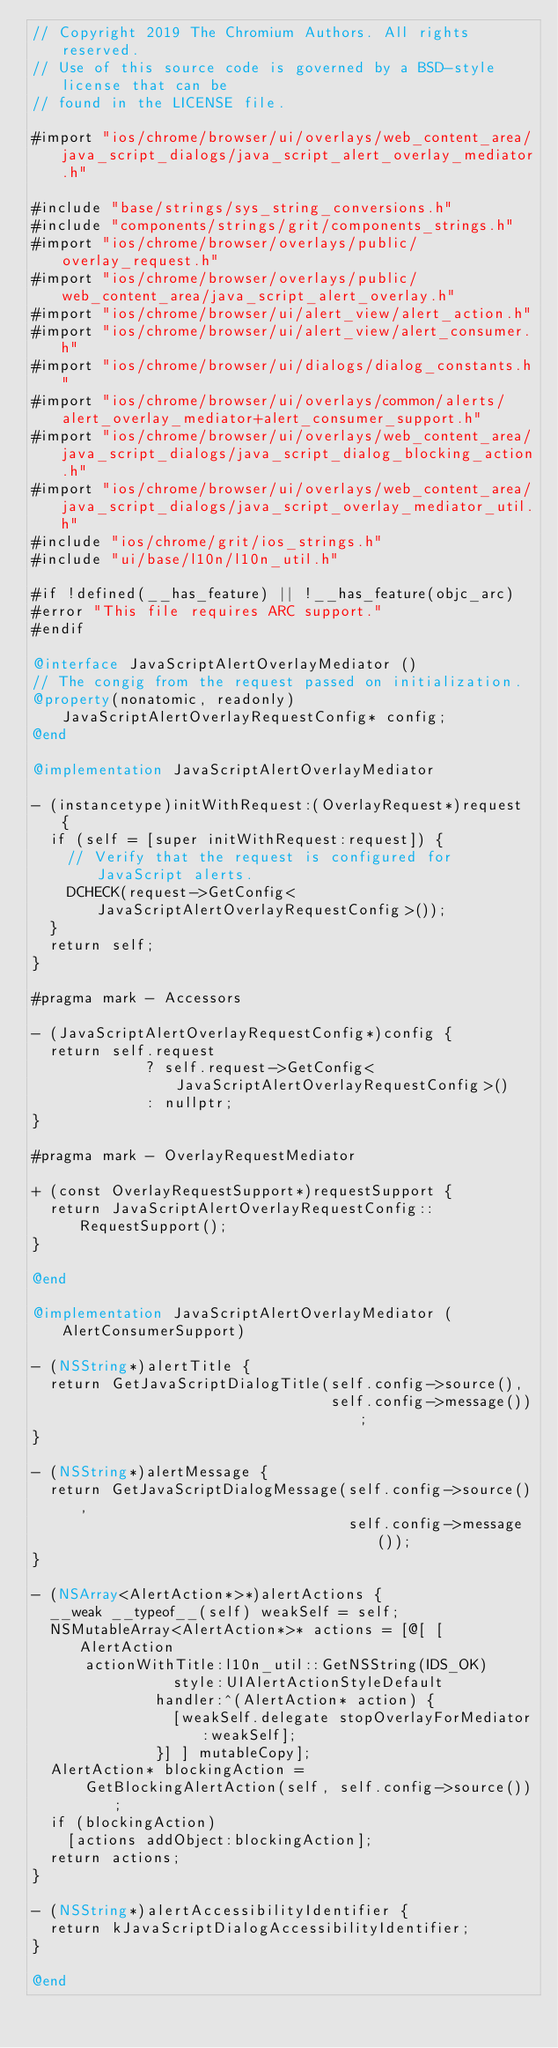<code> <loc_0><loc_0><loc_500><loc_500><_ObjectiveC_>// Copyright 2019 The Chromium Authors. All rights reserved.
// Use of this source code is governed by a BSD-style license that can be
// found in the LICENSE file.

#import "ios/chrome/browser/ui/overlays/web_content_area/java_script_dialogs/java_script_alert_overlay_mediator.h"

#include "base/strings/sys_string_conversions.h"
#include "components/strings/grit/components_strings.h"
#import "ios/chrome/browser/overlays/public/overlay_request.h"
#import "ios/chrome/browser/overlays/public/web_content_area/java_script_alert_overlay.h"
#import "ios/chrome/browser/ui/alert_view/alert_action.h"
#import "ios/chrome/browser/ui/alert_view/alert_consumer.h"
#import "ios/chrome/browser/ui/dialogs/dialog_constants.h"
#import "ios/chrome/browser/ui/overlays/common/alerts/alert_overlay_mediator+alert_consumer_support.h"
#import "ios/chrome/browser/ui/overlays/web_content_area/java_script_dialogs/java_script_dialog_blocking_action.h"
#import "ios/chrome/browser/ui/overlays/web_content_area/java_script_dialogs/java_script_overlay_mediator_util.h"
#include "ios/chrome/grit/ios_strings.h"
#include "ui/base/l10n/l10n_util.h"

#if !defined(__has_feature) || !__has_feature(objc_arc)
#error "This file requires ARC support."
#endif

@interface JavaScriptAlertOverlayMediator ()
// The congig from the request passed on initialization.
@property(nonatomic, readonly) JavaScriptAlertOverlayRequestConfig* config;
@end

@implementation JavaScriptAlertOverlayMediator

- (instancetype)initWithRequest:(OverlayRequest*)request {
  if (self = [super initWithRequest:request]) {
    // Verify that the request is configured for JavaScript alerts.
    DCHECK(request->GetConfig<JavaScriptAlertOverlayRequestConfig>());
  }
  return self;
}

#pragma mark - Accessors

- (JavaScriptAlertOverlayRequestConfig*)config {
  return self.request
             ? self.request->GetConfig<JavaScriptAlertOverlayRequestConfig>()
             : nullptr;
}

#pragma mark - OverlayRequestMediator

+ (const OverlayRequestSupport*)requestSupport {
  return JavaScriptAlertOverlayRequestConfig::RequestSupport();
}

@end

@implementation JavaScriptAlertOverlayMediator (AlertConsumerSupport)

- (NSString*)alertTitle {
  return GetJavaScriptDialogTitle(self.config->source(),
                                  self.config->message());
}

- (NSString*)alertMessage {
  return GetJavaScriptDialogMessage(self.config->source(),
                                    self.config->message());
}

- (NSArray<AlertAction*>*)alertActions {
  __weak __typeof__(self) weakSelf = self;
  NSMutableArray<AlertAction*>* actions = [@[ [AlertAction
      actionWithTitle:l10n_util::GetNSString(IDS_OK)
                style:UIAlertActionStyleDefault
              handler:^(AlertAction* action) {
                [weakSelf.delegate stopOverlayForMediator:weakSelf];
              }] ] mutableCopy];
  AlertAction* blockingAction =
      GetBlockingAlertAction(self, self.config->source());
  if (blockingAction)
    [actions addObject:blockingAction];
  return actions;
}

- (NSString*)alertAccessibilityIdentifier {
  return kJavaScriptDialogAccessibilityIdentifier;
}

@end
</code> 